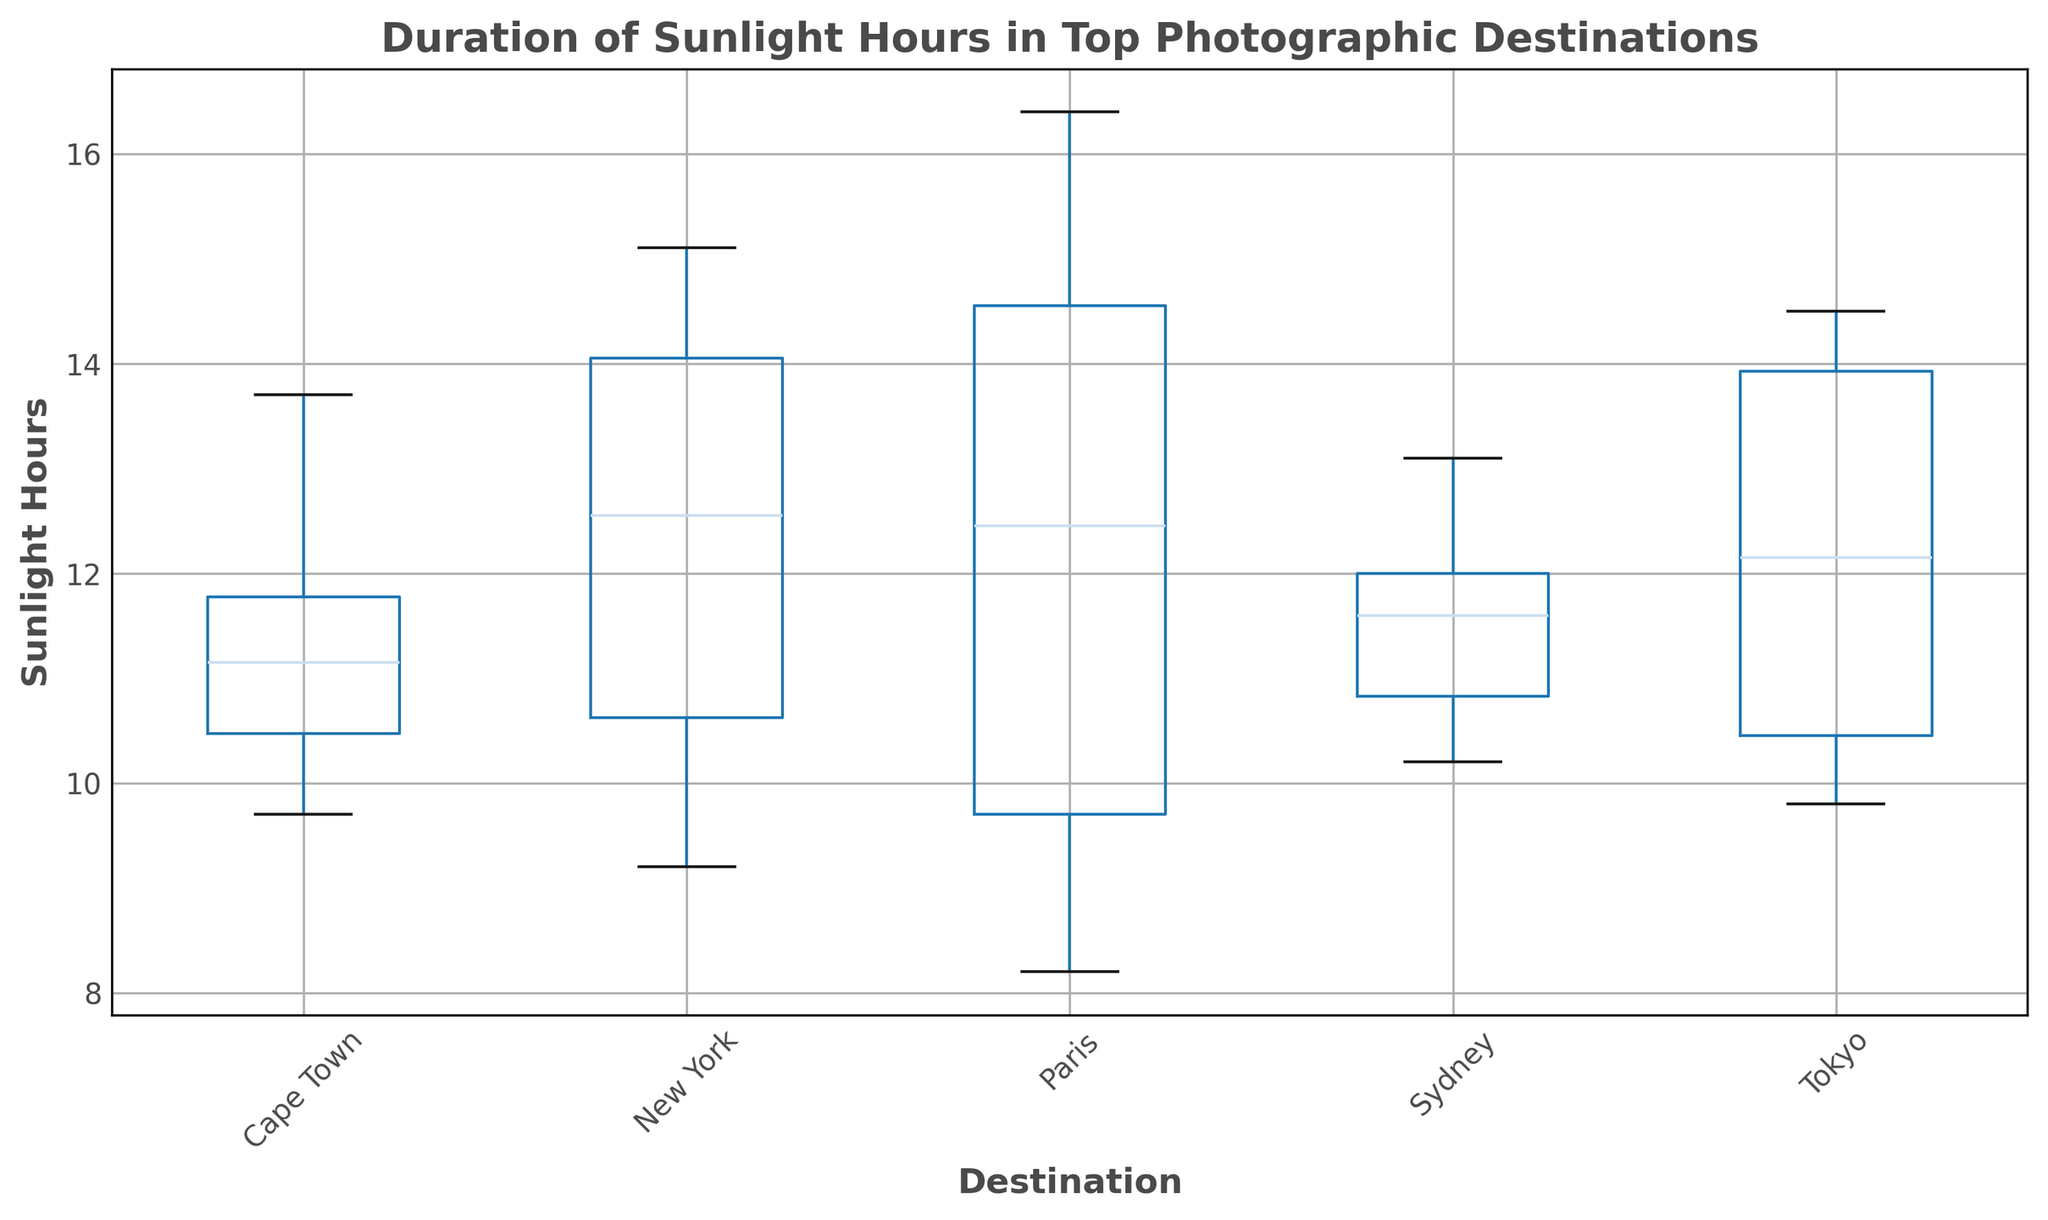Which destination has the highest median sunlight hours? The median sunlight hours can be observed by looking at the line within each box in the box plot. The highest median corresponds to the destination with the highest line relative to others.
Answer: Cape Town Which destination experiences the most variation in sunlight hours? Variation in sunlight hours can be determined by the length of the box, also known as the interquartile range (IQR), and the distance between the whiskers. The destination with the longest box will have the highest variation.
Answer: Paris Which month typically has the least sunlight hours in New York? In a box plot, each box's position on the vertical axis represents the sunlight hours for each month. The lowest position indicates the least sunlight hours.
Answer: December How does the median sunlight hours in Sydney compare to that in Paris? Compare the lines inside the boxes of Sydney and Paris. Find the positions of the lines relative to each other.
Answer: Higher in Paris Which destination has the most consistent sunlight hours throughout the year? The consistency of sunlight hours is represented by the shortest box and smallest range of the whiskers on the box plot.
Answer: Sydney Which two destinations have very similar median sunlight hours? Look at the lines inside the boxes and compare their vertical positions. Identify the destinations with lines at approximately the same height.
Answer: New York and Tokyo During which month is the range of sunlight hours smallest in Tokyo? The smallest range can be found by identifying the month in Tokyo's box plot that has the smallest whiskers span.
Answer: June What is the maximum sunlight hours recorded in Cape Town? The maximum value is represented by the upper whisker tip in Cape Town's box plot.
Answer: 13.7 hours Which destination has the widest interquartile range for sunlight hours? The interquartile range is depicted by the length of the box. Compare the lengths of the boxes to determine the widest one.
Answer: Paris 